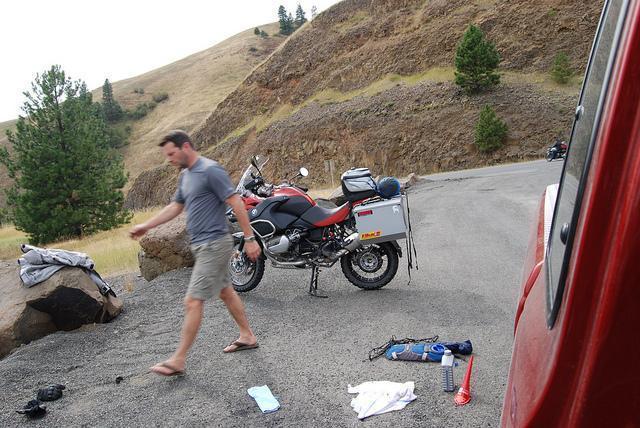Is the statement "The person is far away from the truck." accurate regarding the image?
Answer yes or no. No. 